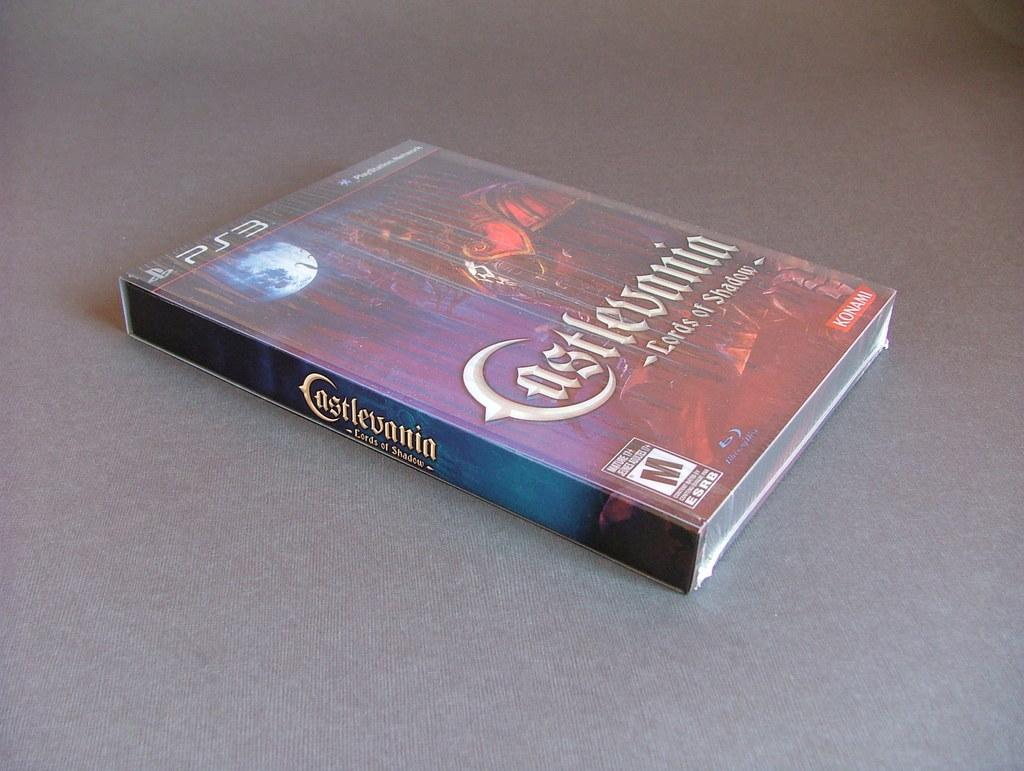Provide a one-sentence caption for the provided image. a video game called castlevania for mature players. 